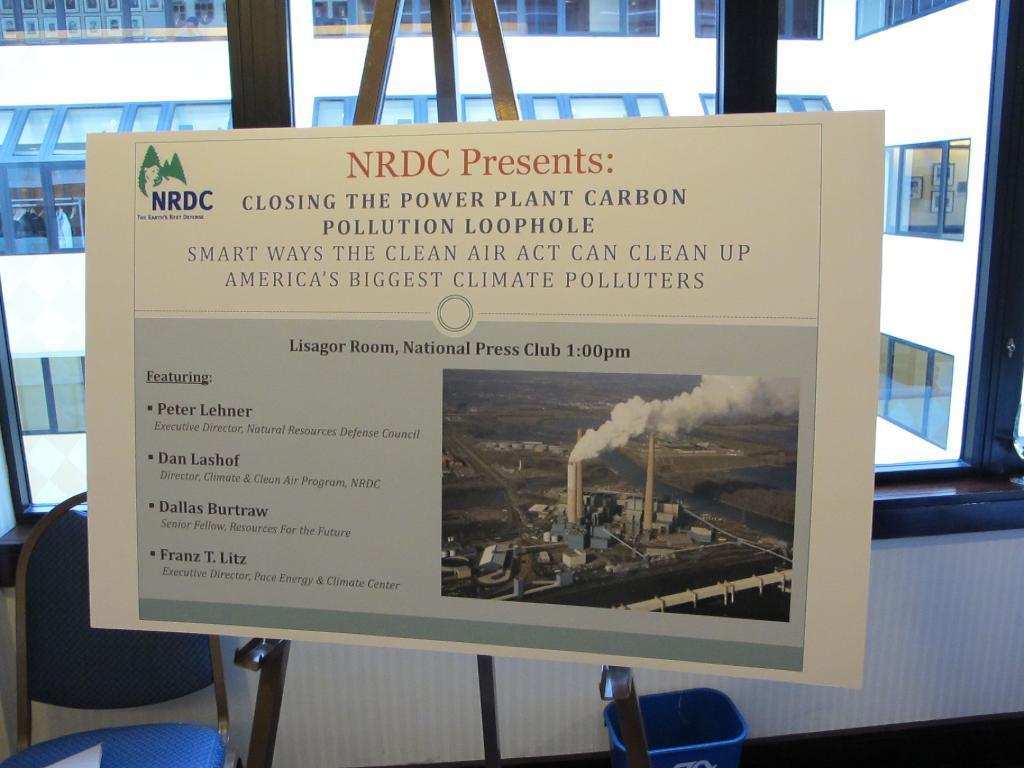Describe this image in one or two sentences. In this image we can see the board which is attached to the stand in which there is some text and picture and in the background of the image there is chair, glass window through which we can see building. 